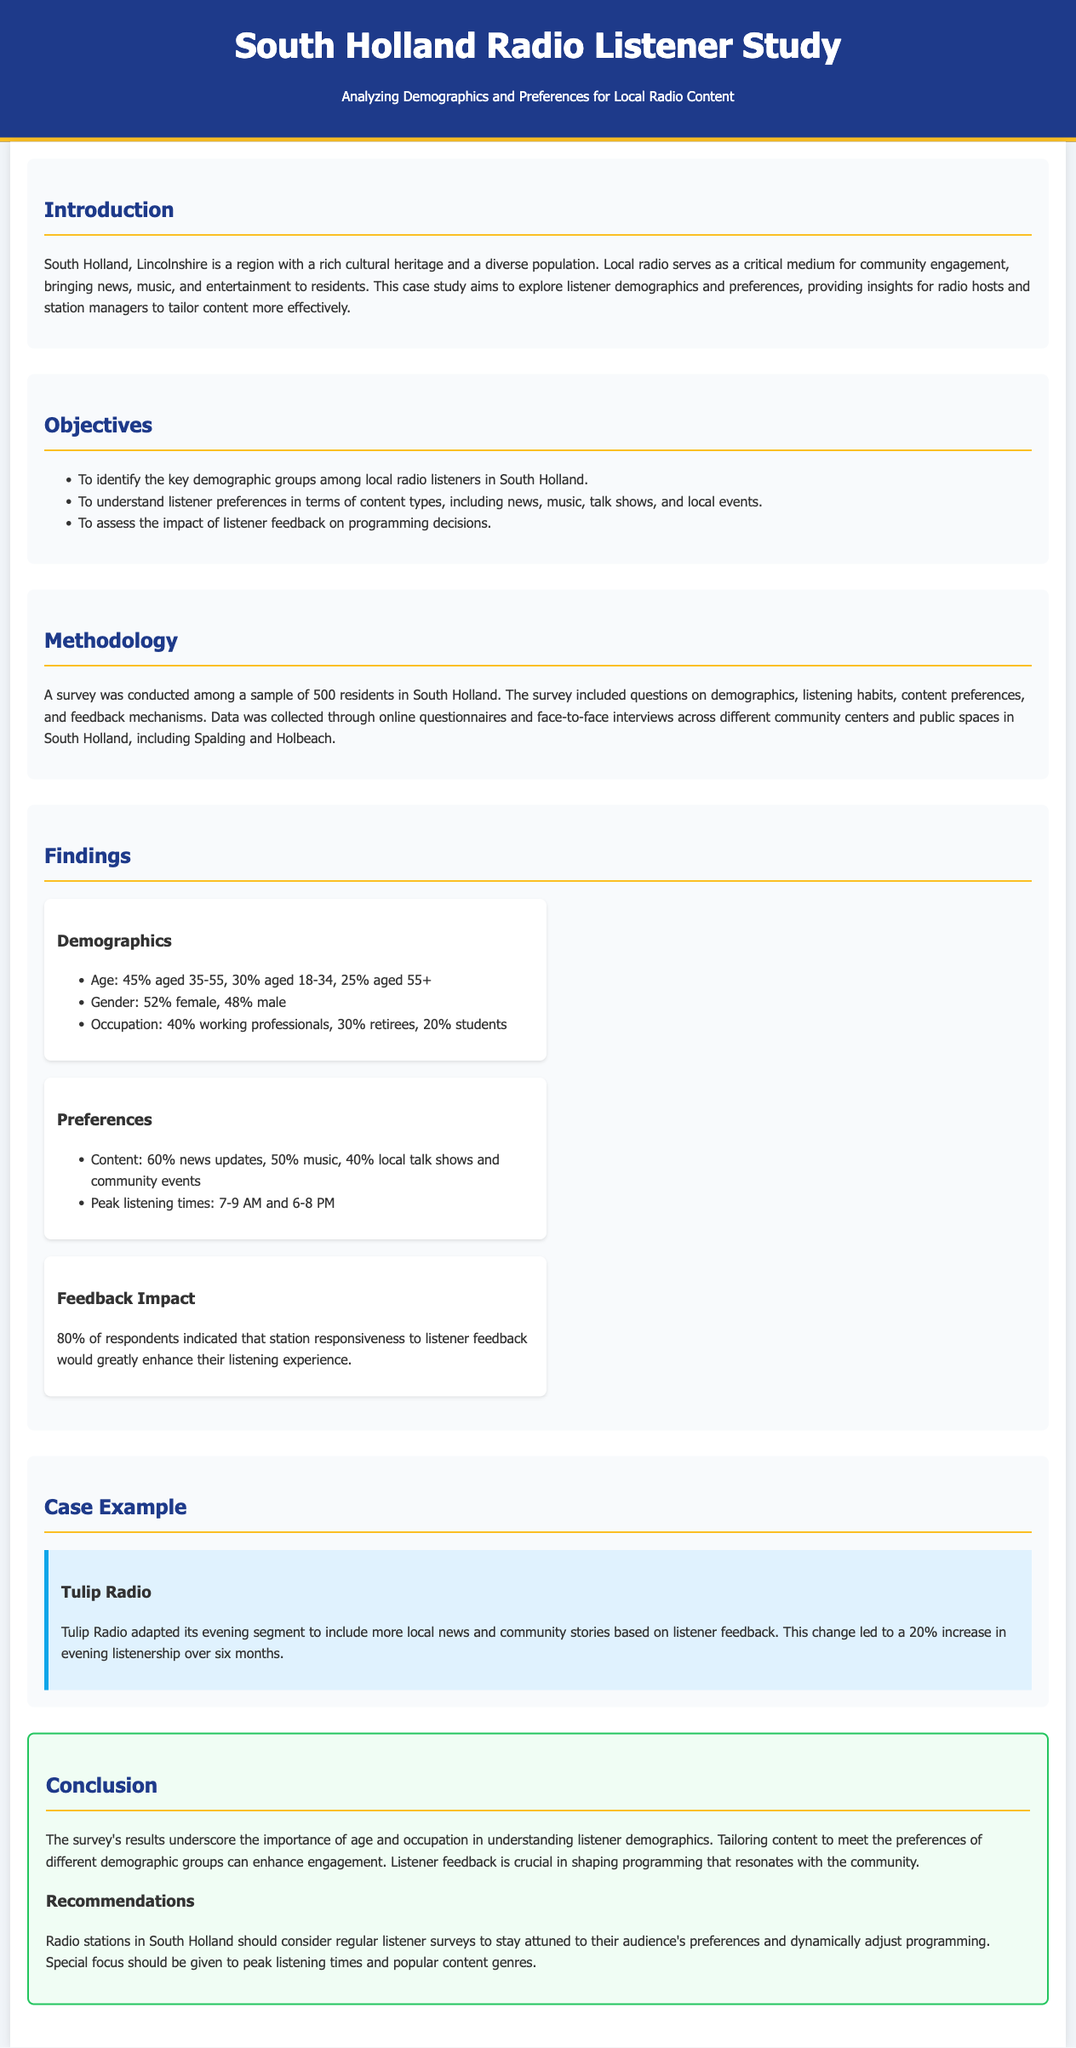what percentage of listeners are aged 35-55? The document reports that 45% of listeners fall within the age group of 35-55.
Answer: 45% what type of content do 60% of listeners prefer? The study indicates that 60% of respondents prefer news updates as their content type.
Answer: news updates what are the peak listening times mentioned? The document states that peak listening times are between 7-9 AM and 6-8 PM.
Answer: 7-9 AM and 6-8 PM how many community centers were involved in the survey? The document mentions that data was collected across different community centers in South Holland, but does not specify a number.
Answer: unspecified what percentage of respondents believe feedback improves their experience? According to the findings, 80% of respondents indicated that station responsiveness to listener feedback greatly enhances their experience.
Answer: 80% what is the main objective of the case study? The primary objective outlined in the document is to identify the key demographic groups among local radio listeners.
Answer: identify key demographic groups how much did Tulip Radio's evening listenership increase? The case example indicates that there was a 20% increase in evening listenership after changes were made.
Answer: 20% what is the gender distribution among the listeners? The findings reveal that 52% of listeners are female and 48% are male.
Answer: 52% female, 48% male 